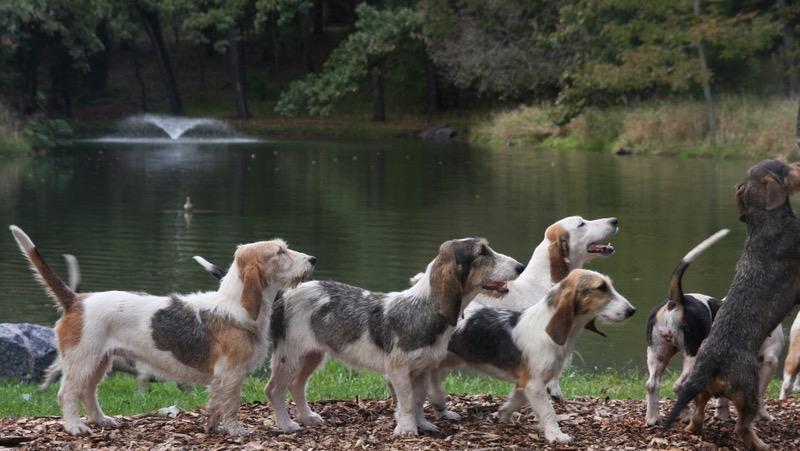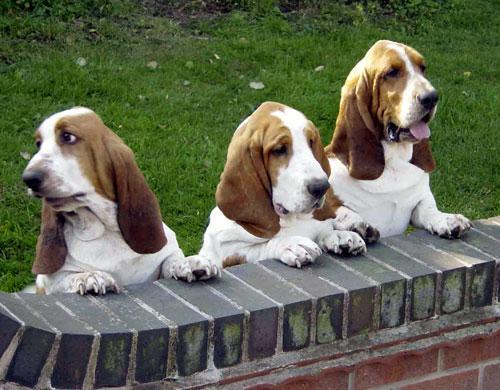The first image is the image on the left, the second image is the image on the right. Considering the images on both sides, is "In each image there are exactly three dogs right next to each other." valid? Answer yes or no. No. 